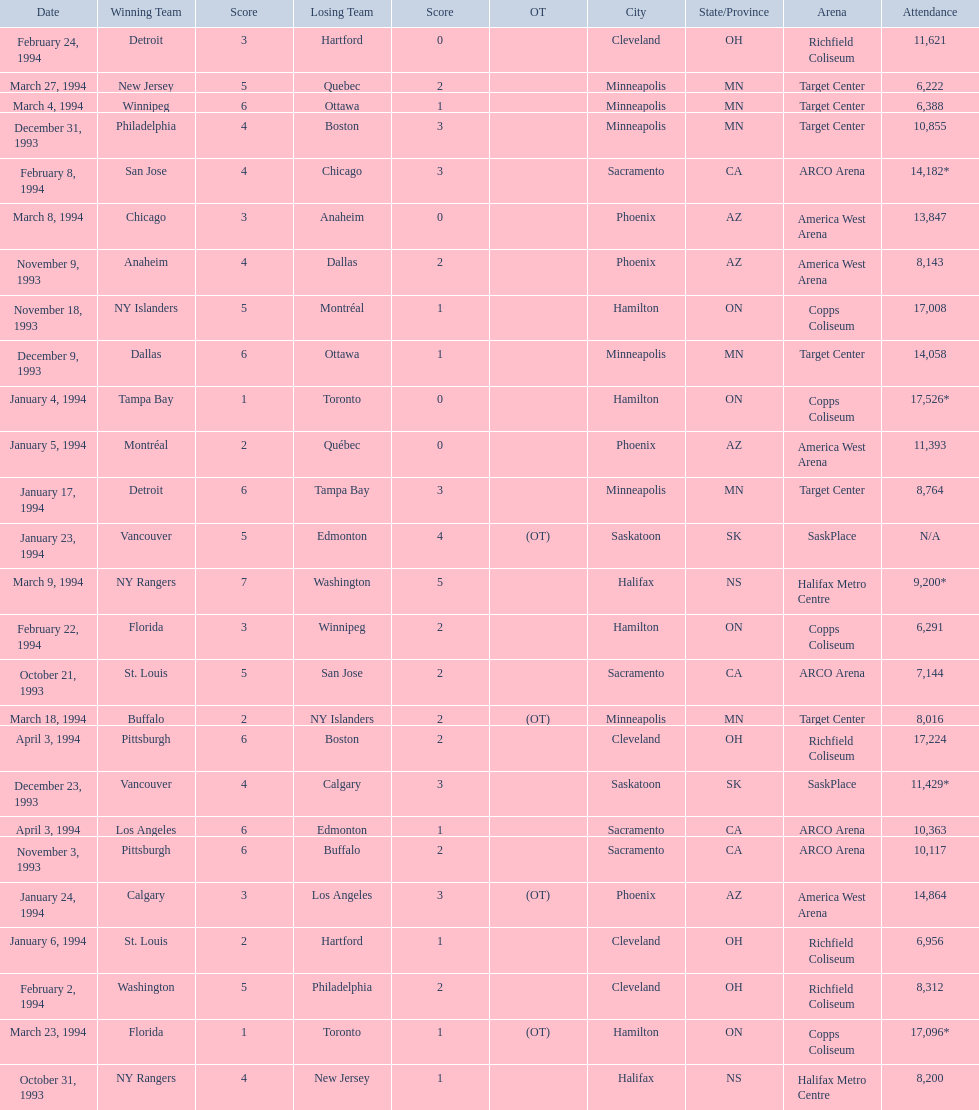On which dates were all the games? October 21, 1993, October 31, 1993, November 3, 1993, November 9, 1993, November 18, 1993, December 9, 1993, December 23, 1993, December 31, 1993, January 4, 1994, January 5, 1994, January 6, 1994, January 17, 1994, January 23, 1994, January 24, 1994, February 2, 1994, February 8, 1994, February 22, 1994, February 24, 1994, March 4, 1994, March 8, 1994, March 9, 1994, March 18, 1994, March 23, 1994, March 27, 1994, April 3, 1994, April 3, 1994. What were the attendances? 7,144, 8,200, 10,117, 8,143, 17,008, 14,058, 11,429*, 10,855, 17,526*, 11,393, 6,956, 8,764, N/A, 14,864, 8,312, 14,182*, 6,291, 11,621, 6,388, 13,847, 9,200*, 8,016, 17,096*, 6,222, 17,224, 10,363. And between december 23, 1993 and january 24, 1994, which game had the highest turnout? January 4, 1994. 